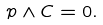Convert formula to latex. <formula><loc_0><loc_0><loc_500><loc_500>p \land C = 0 .</formula> 